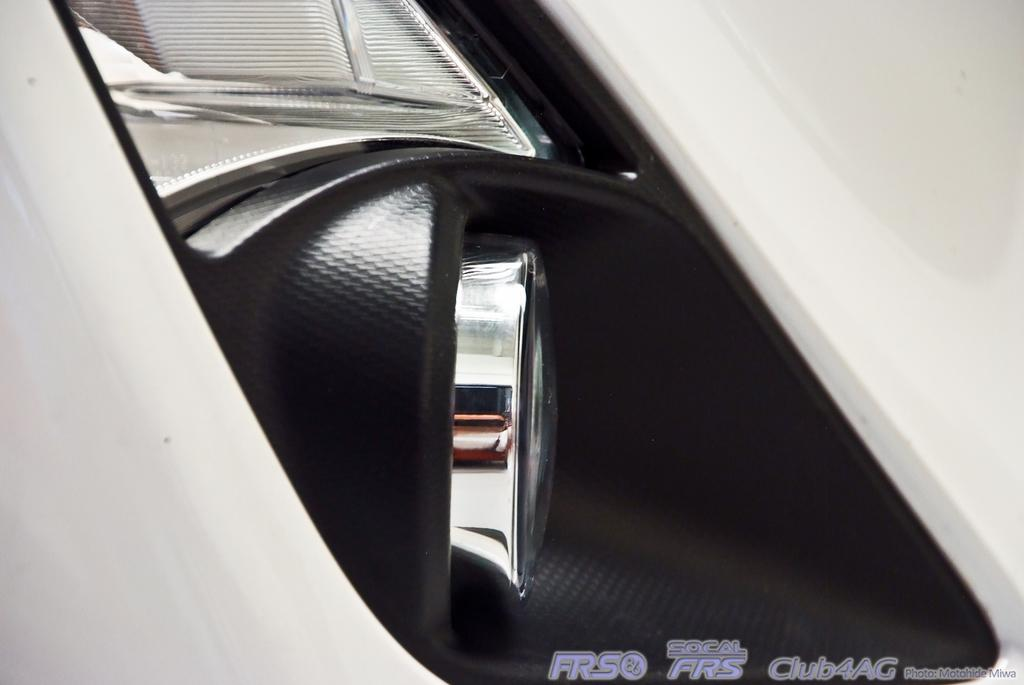What is the main subject of the image? The main subject of the image is a headlight of a vehicle. How many times did you brush your teeth this week? The image does not provide any information about brushing teeth or the passage of time, so this question cannot be answered definitively from the image. 